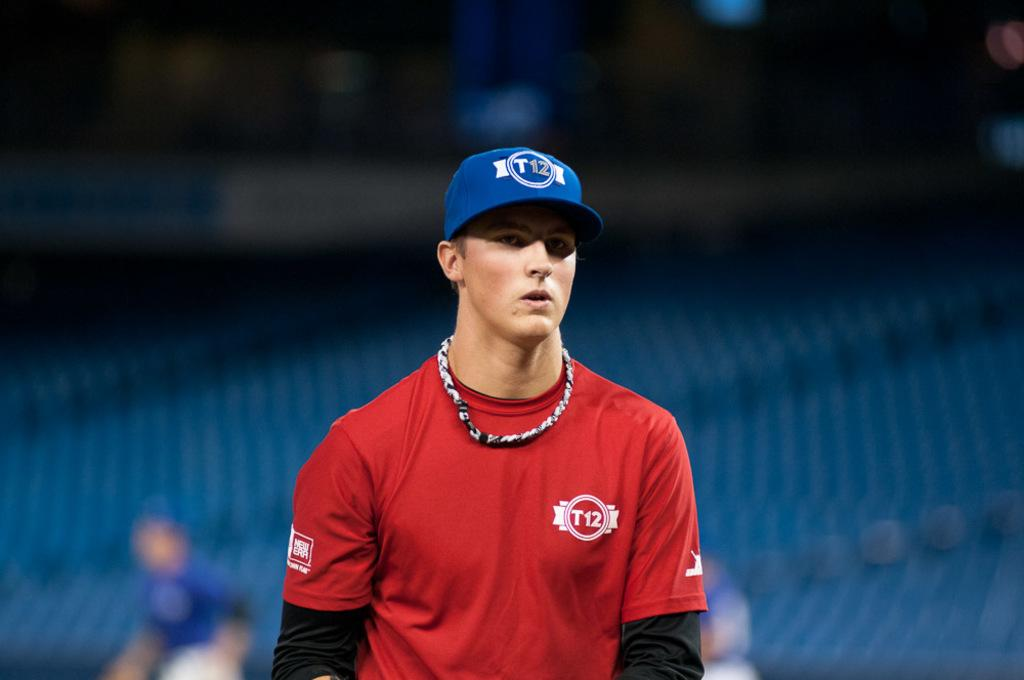<image>
Give a short and clear explanation of the subsequent image. A man stands in a stadium wearing a blue hat and red shirt, both marked with T12. 